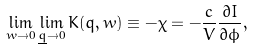Convert formula to latex. <formula><loc_0><loc_0><loc_500><loc_500>\lim _ { w \rightarrow 0 } \lim _ { \underline { q } \rightarrow 0 } K ( q , w ) \equiv - \chi = - \frac { c } { V } \frac { \partial I } { \partial \phi } ,</formula> 